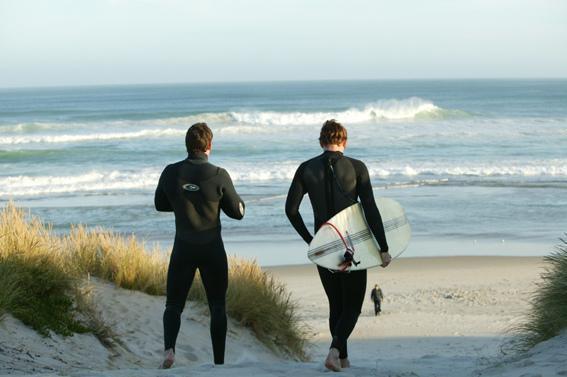Why do they have black suits on?
Make your selection from the four choices given to correctly answer the question.
Options: Disguise, stay cool, are twins, stay warm. Stay warm. 